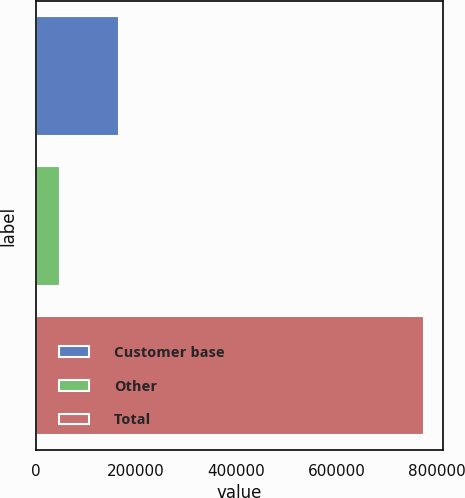<chart> <loc_0><loc_0><loc_500><loc_500><bar_chart><fcel>Customer base<fcel>Other<fcel>Total<nl><fcel>166073<fcel>47732<fcel>772914<nl></chart> 